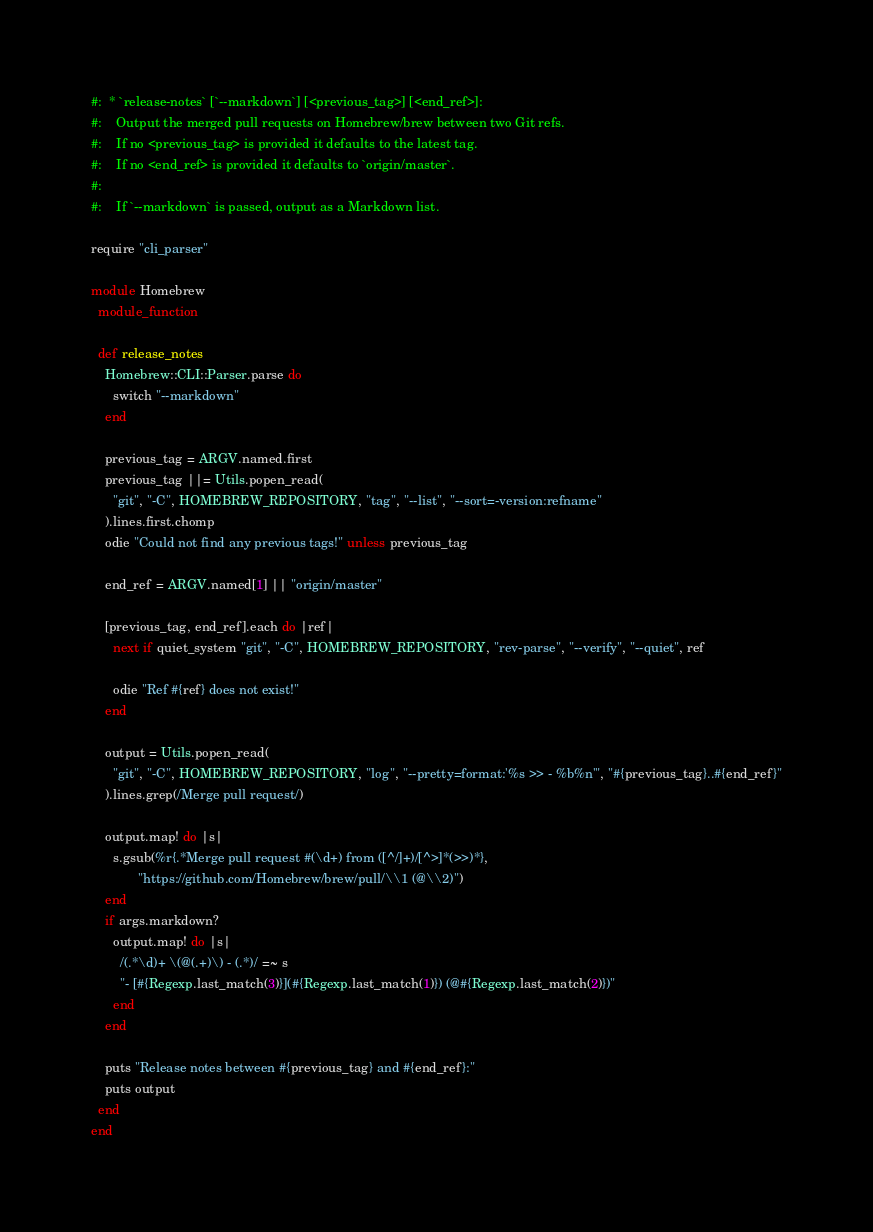Convert code to text. <code><loc_0><loc_0><loc_500><loc_500><_Ruby_>#:  * `release-notes` [`--markdown`] [<previous_tag>] [<end_ref>]:
#:    Output the merged pull requests on Homebrew/brew between two Git refs.
#:    If no <previous_tag> is provided it defaults to the latest tag.
#:    If no <end_ref> is provided it defaults to `origin/master`.
#:
#:    If `--markdown` is passed, output as a Markdown list.

require "cli_parser"

module Homebrew
  module_function

  def release_notes
    Homebrew::CLI::Parser.parse do
      switch "--markdown"
    end

    previous_tag = ARGV.named.first
    previous_tag ||= Utils.popen_read(
      "git", "-C", HOMEBREW_REPOSITORY, "tag", "--list", "--sort=-version:refname"
    ).lines.first.chomp
    odie "Could not find any previous tags!" unless previous_tag

    end_ref = ARGV.named[1] || "origin/master"

    [previous_tag, end_ref].each do |ref|
      next if quiet_system "git", "-C", HOMEBREW_REPOSITORY, "rev-parse", "--verify", "--quiet", ref

      odie "Ref #{ref} does not exist!"
    end

    output = Utils.popen_read(
      "git", "-C", HOMEBREW_REPOSITORY, "log", "--pretty=format:'%s >> - %b%n'", "#{previous_tag}..#{end_ref}"
    ).lines.grep(/Merge pull request/)

    output.map! do |s|
      s.gsub(%r{.*Merge pull request #(\d+) from ([^/]+)/[^>]*(>>)*},
             "https://github.com/Homebrew/brew/pull/\\1 (@\\2)")
    end
    if args.markdown?
      output.map! do |s|
        /(.*\d)+ \(@(.+)\) - (.*)/ =~ s
        "- [#{Regexp.last_match(3)}](#{Regexp.last_match(1)}) (@#{Regexp.last_match(2)})"
      end
    end

    puts "Release notes between #{previous_tag} and #{end_ref}:"
    puts output
  end
end
</code> 